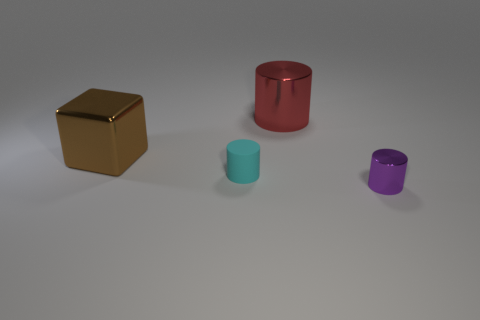There is a cylinder that is behind the cube; is it the same size as the metal thing to the left of the red thing?
Your answer should be compact. Yes. How many large blocks are made of the same material as the purple cylinder?
Keep it short and to the point. 1. What number of cyan cylinders are right of the tiny thing that is left of the big thing that is behind the cube?
Your response must be concise. 0. Do the tiny rubber object and the red thing have the same shape?
Ensure brevity in your answer.  Yes. Is there a gray object of the same shape as the big brown metallic thing?
Provide a short and direct response. No. What is the shape of the other metal object that is the same size as the cyan object?
Give a very brief answer. Cylinder. The tiny object left of the large red shiny object left of the shiny thing that is right of the large red metal object is made of what material?
Give a very brief answer. Rubber. Do the red thing and the cyan cylinder have the same size?
Make the answer very short. No. What is the material of the brown object?
Your answer should be compact. Metal. Does the large metal thing to the right of the large brown cube have the same shape as the large brown object?
Offer a terse response. No. 